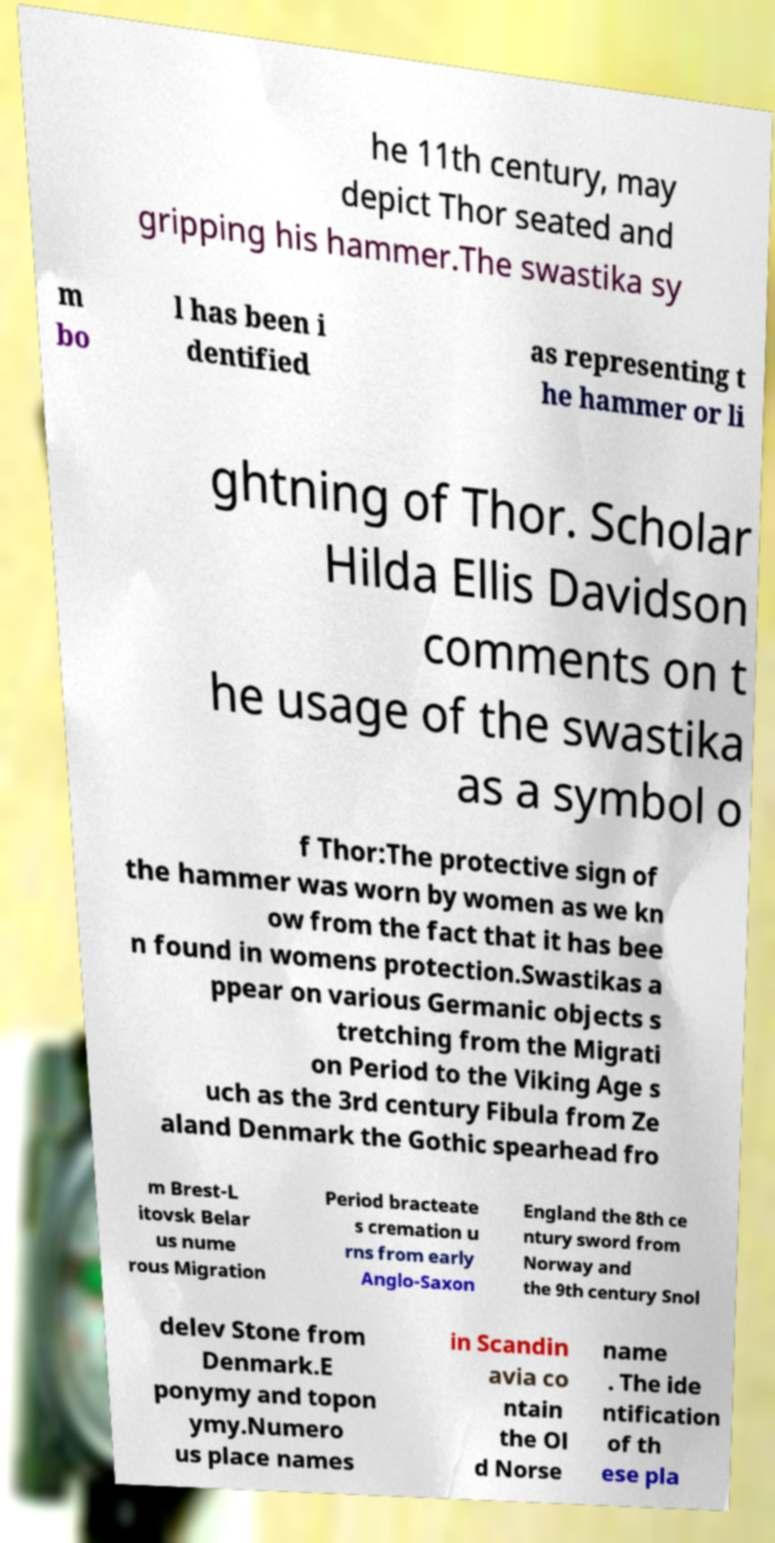What messages or text are displayed in this image? I need them in a readable, typed format. he 11th century, may depict Thor seated and gripping his hammer.The swastika sy m bo l has been i dentified as representing t he hammer or li ghtning of Thor. Scholar Hilda Ellis Davidson comments on t he usage of the swastika as a symbol o f Thor:The protective sign of the hammer was worn by women as we kn ow from the fact that it has bee n found in womens protection.Swastikas a ppear on various Germanic objects s tretching from the Migrati on Period to the Viking Age s uch as the 3rd century Fibula from Ze aland Denmark the Gothic spearhead fro m Brest-L itovsk Belar us nume rous Migration Period bracteate s cremation u rns from early Anglo-Saxon England the 8th ce ntury sword from Norway and the 9th century Snol delev Stone from Denmark.E ponymy and topon ymy.Numero us place names in Scandin avia co ntain the Ol d Norse name . The ide ntification of th ese pla 